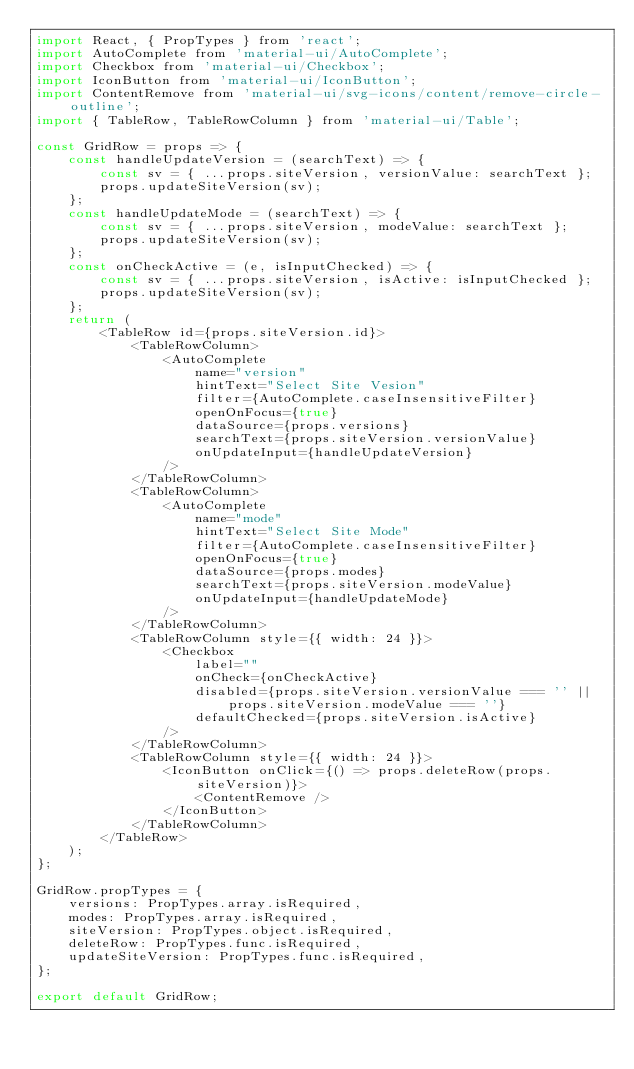<code> <loc_0><loc_0><loc_500><loc_500><_JavaScript_>import React, { PropTypes } from 'react';
import AutoComplete from 'material-ui/AutoComplete';
import Checkbox from 'material-ui/Checkbox';
import IconButton from 'material-ui/IconButton';
import ContentRemove from 'material-ui/svg-icons/content/remove-circle-outline';
import { TableRow, TableRowColumn } from 'material-ui/Table';

const GridRow = props => {
	const handleUpdateVersion = (searchText) => {
		const sv = { ...props.siteVersion, versionValue: searchText };
		props.updateSiteVersion(sv);
	};
	const handleUpdateMode = (searchText) => {
		const sv = { ...props.siteVersion, modeValue: searchText };
		props.updateSiteVersion(sv);
	};
	const onCheckActive = (e, isInputChecked) => {
		const sv = { ...props.siteVersion, isActive: isInputChecked };
		props.updateSiteVersion(sv);
	};
	return (
		<TableRow id={props.siteVersion.id}>
			<TableRowColumn>
				<AutoComplete
					name="version"
					hintText="Select Site Vesion"
					filter={AutoComplete.caseInsensitiveFilter}
					openOnFocus={true}
					dataSource={props.versions}
					searchText={props.siteVersion.versionValue}
					onUpdateInput={handleUpdateVersion}
				/>
			</TableRowColumn>
			<TableRowColumn>
				<AutoComplete
					name="mode"
					hintText="Select Site Mode"
					filter={AutoComplete.caseInsensitiveFilter}
					openOnFocus={true}
					dataSource={props.modes}
					searchText={props.siteVersion.modeValue}
					onUpdateInput={handleUpdateMode}
				/>
			</TableRowColumn>
			<TableRowColumn style={{ width: 24 }}>
				<Checkbox
					label=""
					onCheck={onCheckActive}
					disabled={props.siteVersion.versionValue === '' || props.siteVersion.modeValue === ''}
					defaultChecked={props.siteVersion.isActive}
				/>
			</TableRowColumn>
			<TableRowColumn style={{ width: 24 }}>
				<IconButton onClick={() => props.deleteRow(props.siteVersion)}>
					<ContentRemove />
				</IconButton>
			</TableRowColumn>
		</TableRow>
	);
};

GridRow.propTypes = {
	versions: PropTypes.array.isRequired,
	modes: PropTypes.array.isRequired,
	siteVersion: PropTypes.object.isRequired,
	deleteRow: PropTypes.func.isRequired,
	updateSiteVersion: PropTypes.func.isRequired,
};

export default GridRow;</code> 